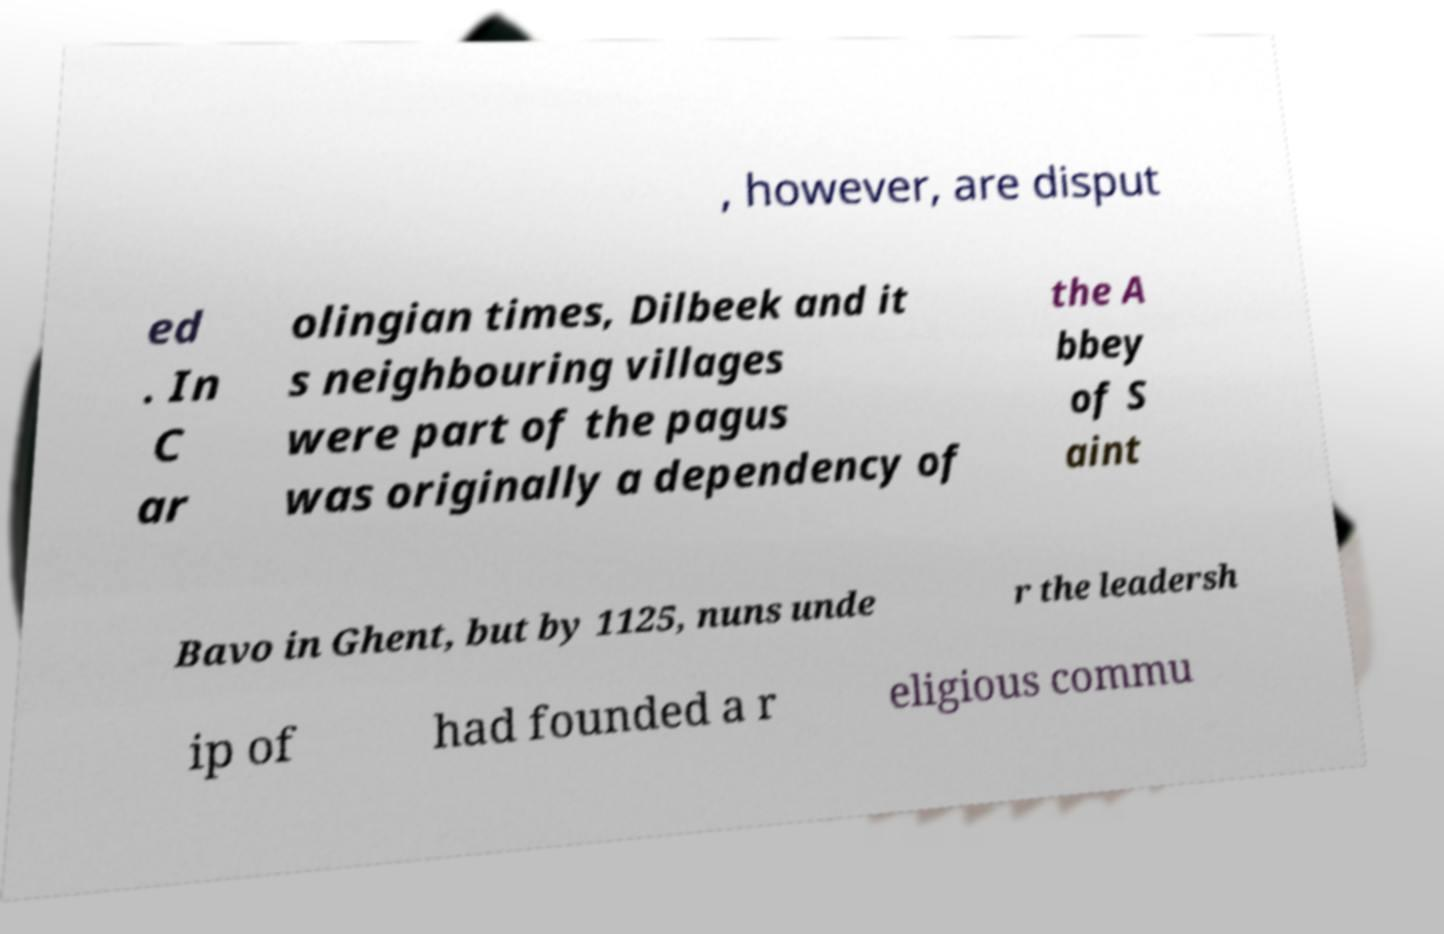For documentation purposes, I need the text within this image transcribed. Could you provide that? , however, are disput ed . In C ar olingian times, Dilbeek and it s neighbouring villages were part of the pagus was originally a dependency of the A bbey of S aint Bavo in Ghent, but by 1125, nuns unde r the leadersh ip of had founded a r eligious commu 